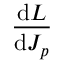<formula> <loc_0><loc_0><loc_500><loc_500>\frac { d L } { d J _ { p } }</formula> 